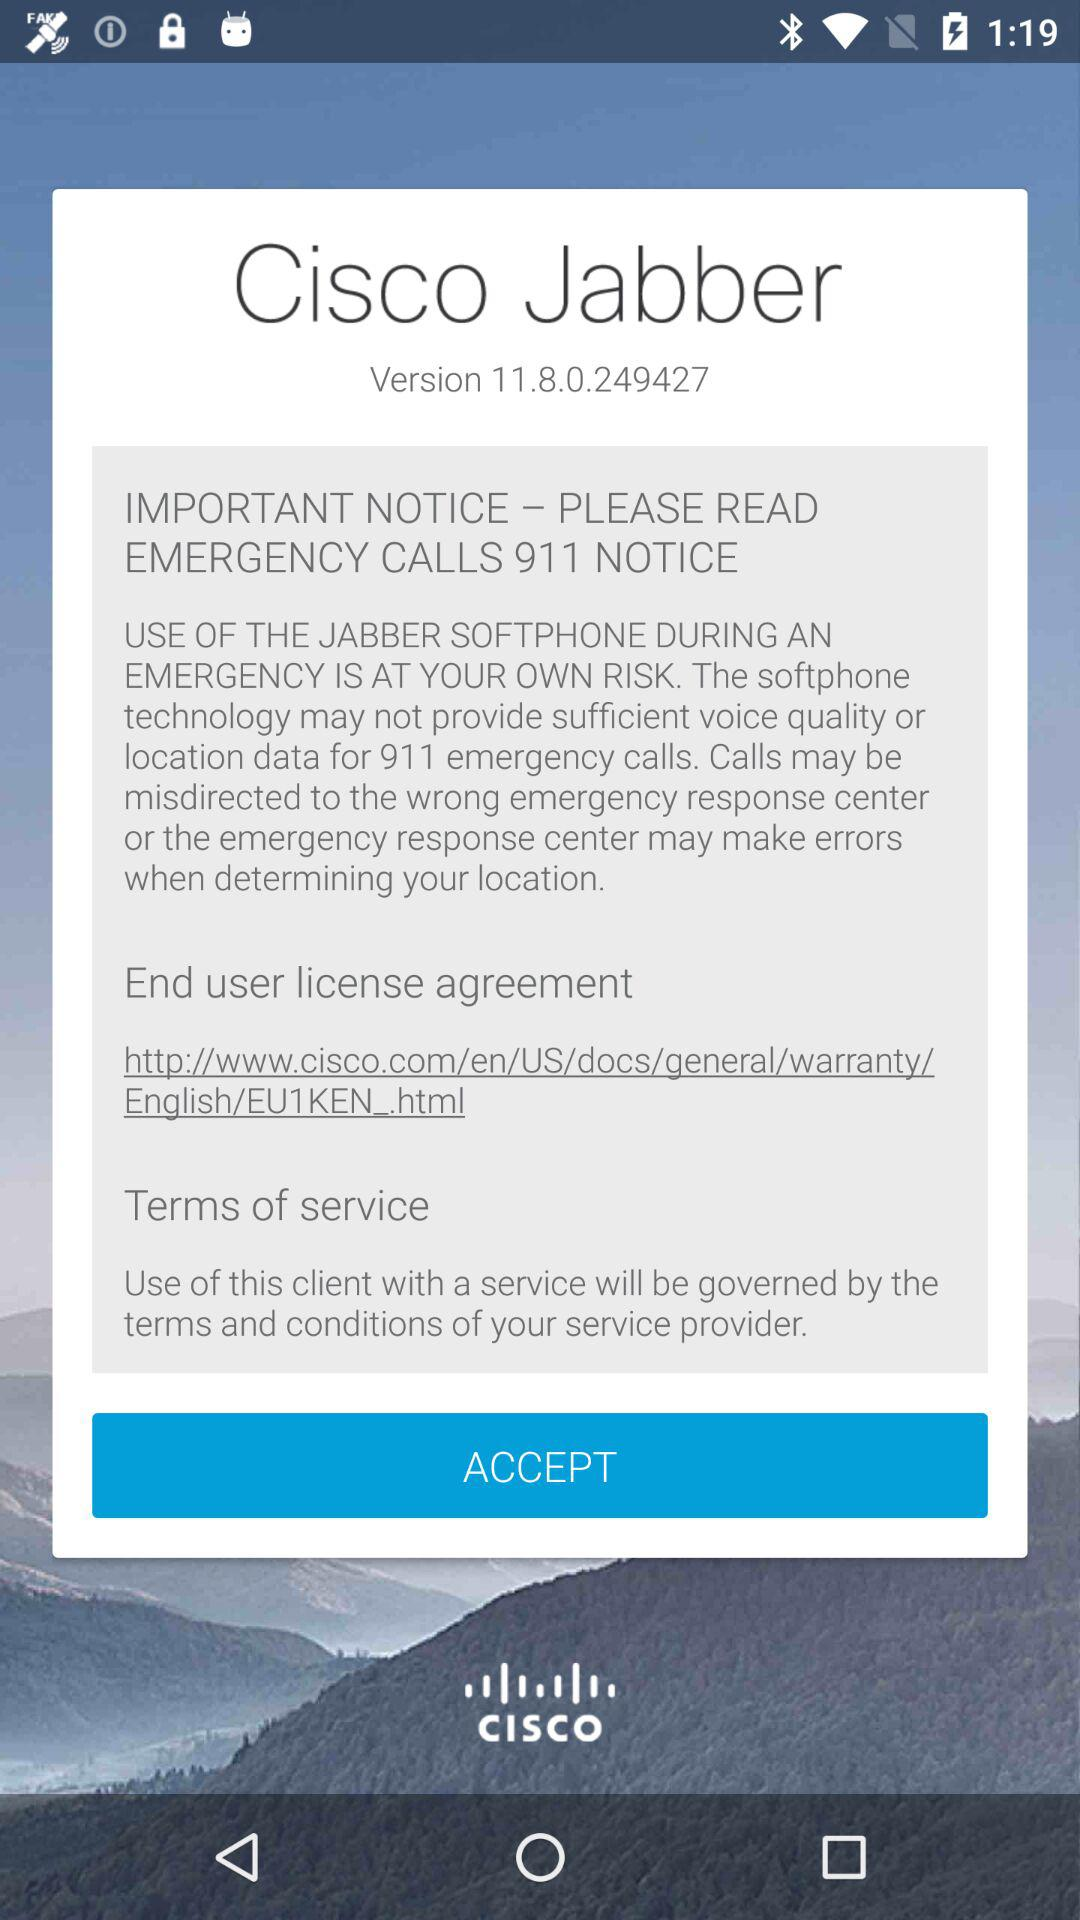What is the application name? The application name is "Cisco Jabber". 